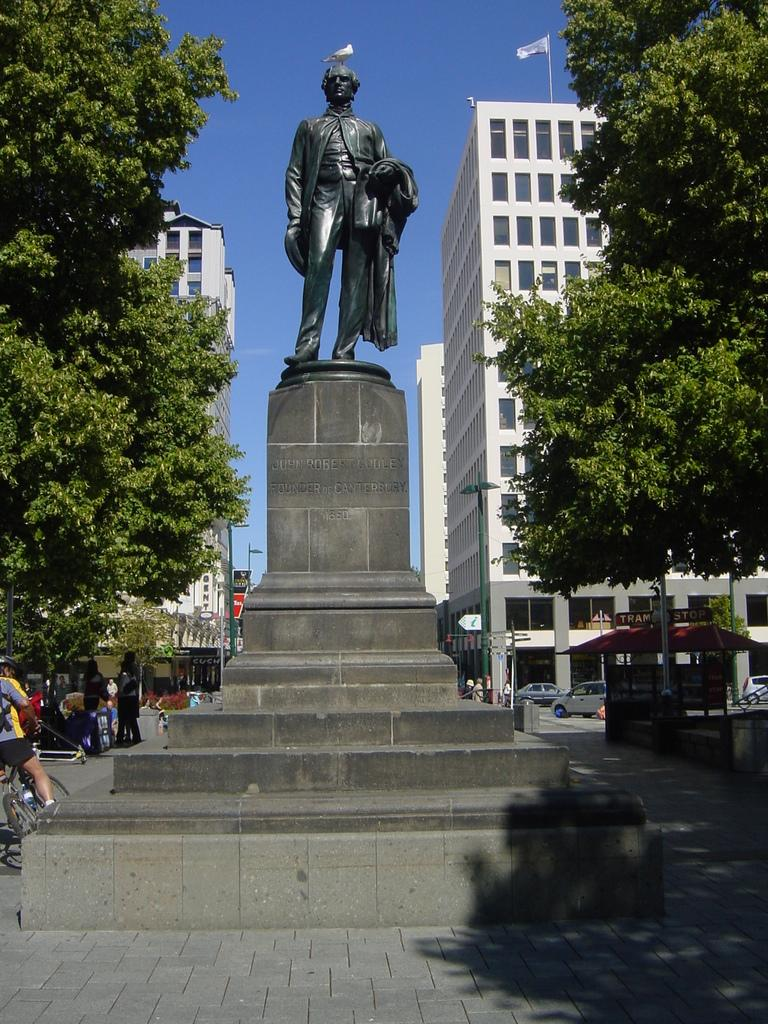What is located in the middle of the road in the image? There is a sculpture in the middle of the road in the image. What else can be seen in the image besides the sculpture? There are vehicles, persons, trees, and buildings visible in the image. What type of structures are present in the image? The buildings in the image are structures. What is the natural element visible in the image? Trees are the natural element visible in the image. What type of dinner is being served in the image? There is no dinner present in the image; it features a sculpture in the middle of the road, vehicles, persons, trees, and buildings. Is there a spy visible in the image? There is no mention of a spy in the image, as it focuses on a sculpture, vehicles, persons, trees, and buildings. 